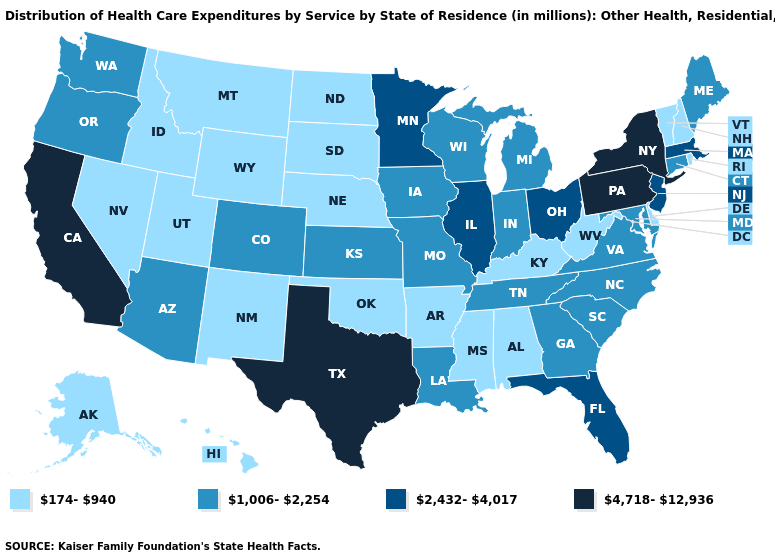What is the value of South Carolina?
Short answer required. 1,006-2,254. What is the value of Louisiana?
Give a very brief answer. 1,006-2,254. Which states have the lowest value in the USA?
Quick response, please. Alabama, Alaska, Arkansas, Delaware, Hawaii, Idaho, Kentucky, Mississippi, Montana, Nebraska, Nevada, New Hampshire, New Mexico, North Dakota, Oklahoma, Rhode Island, South Dakota, Utah, Vermont, West Virginia, Wyoming. What is the highest value in the MidWest ?
Write a very short answer. 2,432-4,017. What is the lowest value in the South?
Short answer required. 174-940. What is the value of Florida?
Give a very brief answer. 2,432-4,017. Among the states that border Arkansas , does Texas have the highest value?
Short answer required. Yes. Is the legend a continuous bar?
Quick response, please. No. Does Wyoming have the lowest value in the USA?
Concise answer only. Yes. Does the map have missing data?
Be succinct. No. What is the value of Oregon?
Concise answer only. 1,006-2,254. Which states have the lowest value in the USA?
Be succinct. Alabama, Alaska, Arkansas, Delaware, Hawaii, Idaho, Kentucky, Mississippi, Montana, Nebraska, Nevada, New Hampshire, New Mexico, North Dakota, Oklahoma, Rhode Island, South Dakota, Utah, Vermont, West Virginia, Wyoming. What is the value of Idaho?
Write a very short answer. 174-940. Name the states that have a value in the range 4,718-12,936?
Concise answer only. California, New York, Pennsylvania, Texas. What is the lowest value in states that border Minnesota?
Answer briefly. 174-940. 